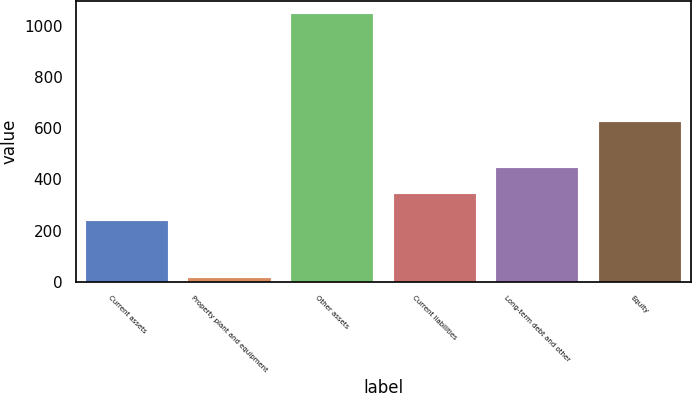Convert chart to OTSL. <chart><loc_0><loc_0><loc_500><loc_500><bar_chart><fcel>Current assets<fcel>Property plant and equipment<fcel>Other assets<fcel>Current liabilities<fcel>Long-term debt and other<fcel>Equity<nl><fcel>239<fcel>15<fcel>1047<fcel>342.2<fcel>445.4<fcel>626<nl></chart> 